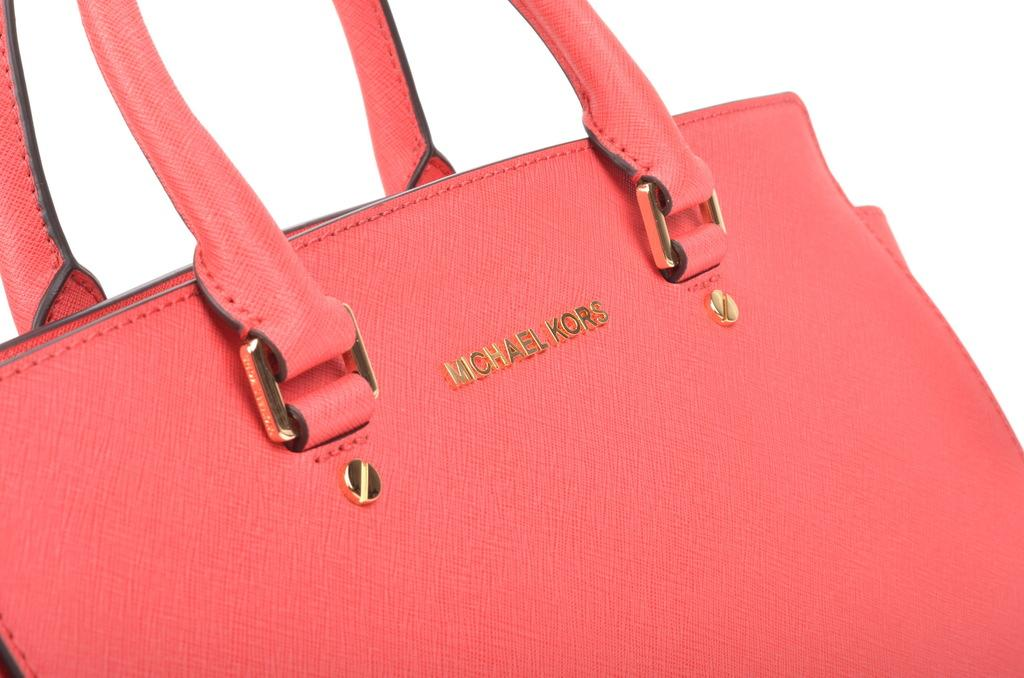What color is the bag in the image? The bag is red in color. What brand is the bag? The bag is a Michael Kors brand. How many handles does the bag have, and what color are they? The bag has two red color handles. What is the color of the background in the image? The background is white. Can you see a robin taking a bite out of the bag in the image? No, there is no robin or any indication of a bite taken out of the bag in the image. 